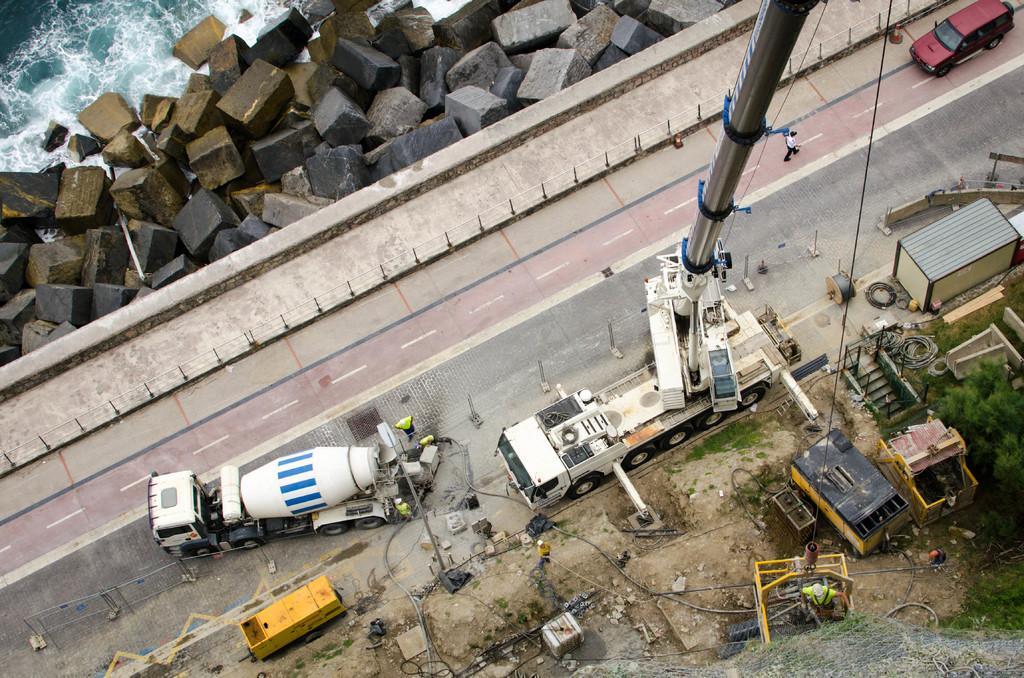Please provide a concise description of this image. There are lorries and brown color car on the road, on which, there is a person walking, near a footpath. On the right side, there is a building, near shelters and trees. In the background, there are rocks near water of the ocean. 